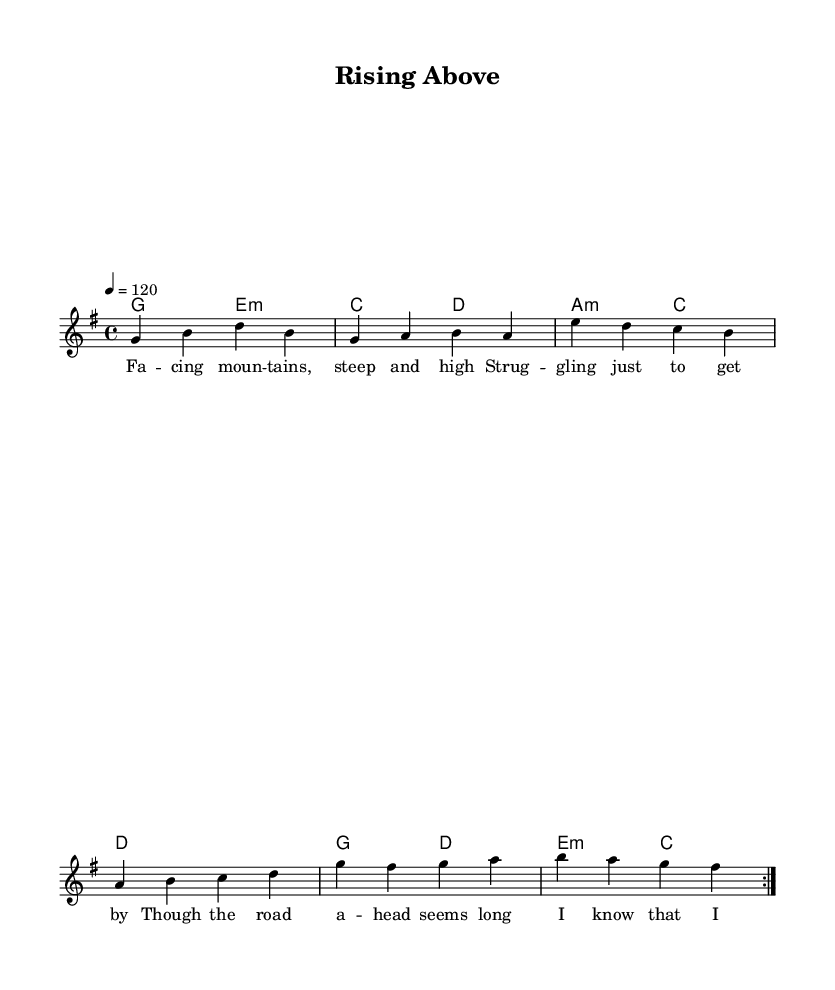What is the key signature of this music? The key signature is G major, which contains one sharp (F#). This can be determined by looking at the key signature notation at the beginning of the score.
Answer: G major What is the time signature of this music? The time signature is 4/4, meaning there are four beats per measure, and the quarter note gets one beat. This is indicated at the start of the score.
Answer: 4/4 What is the tempo marking in this piece? The tempo marking is 120 beats per minute, indicated by the tempo marking at the beginning of the score. This tells musicians how fast to play the music.
Answer: 120 How many measures are in the melody section? The melody section consists of 8 measures, as indicated by the repeating patterns and the measure lines present in the sheet music.
Answer: 8 What is the primary theme of the lyrics? The primary theme of the lyrics is resilience and overcoming challenges, as illustrated by phrases about rising above obstacles and staying strong despite struggles.
Answer: Resilience Which chord is played in the first measure? The first measure features the G major chord, which can be identified by the chord name notated beneath the staff in the sheet music.
Answer: G What is the form of the piece based on the structure? The form of the piece is verse-based with a repeated section, indicated by the volta markings that suggest repetition of the musical phrases.
Answer: Verse-based 